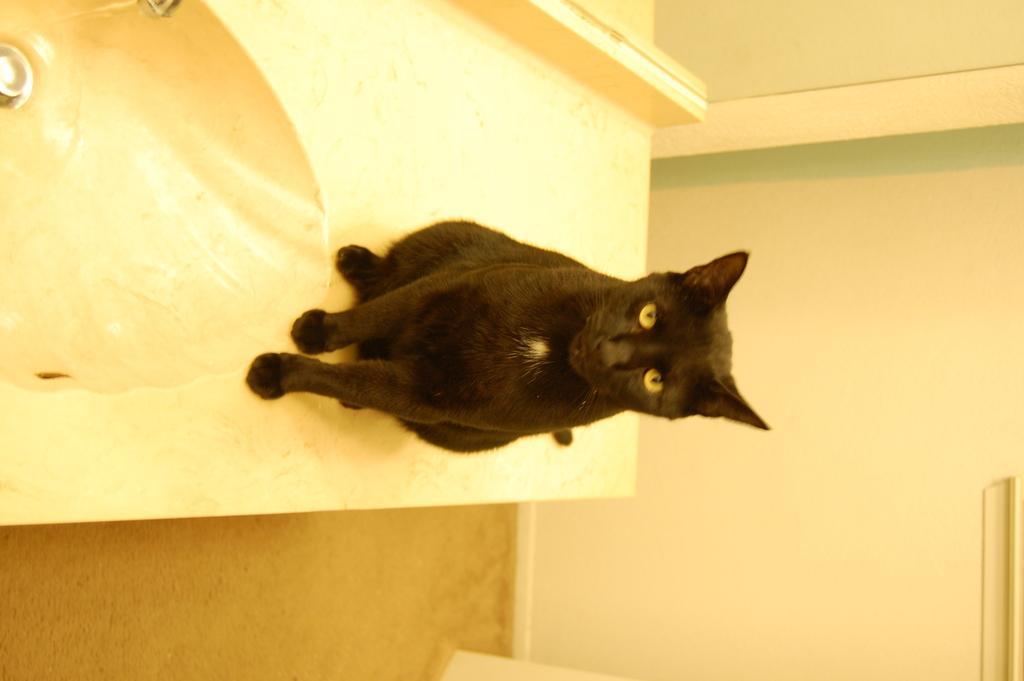In one or two sentences, can you explain what this image depicts? In this image we can see a cat beside a sink. On the right side we can see a wall. 